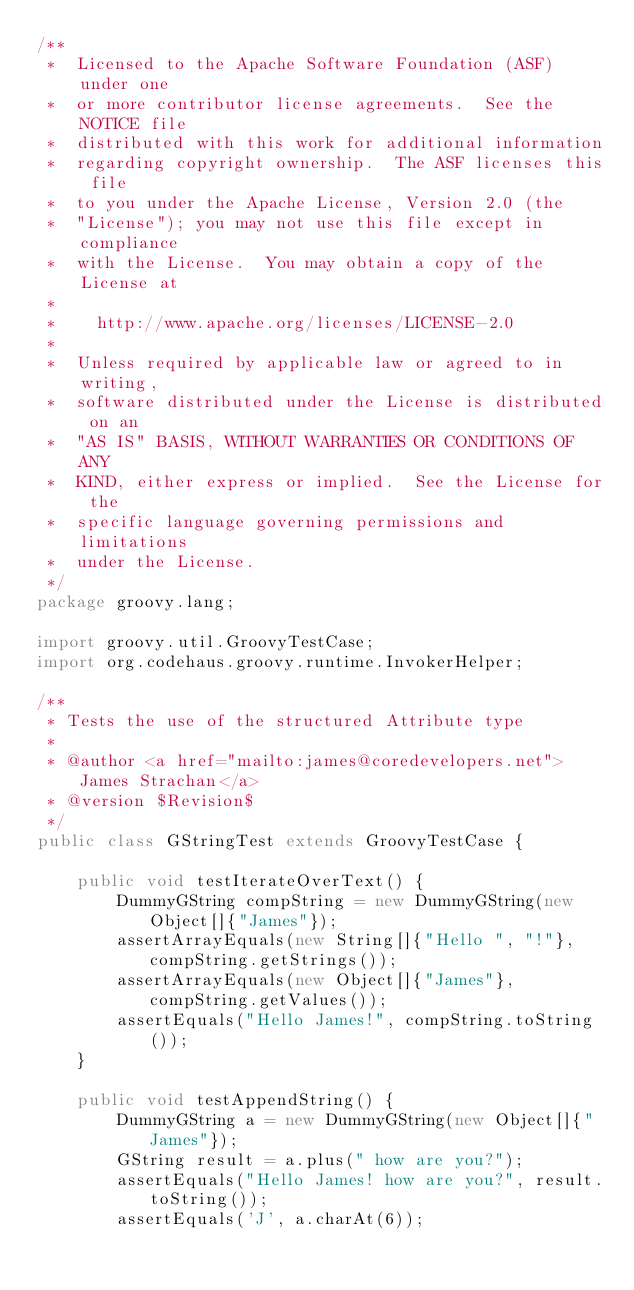<code> <loc_0><loc_0><loc_500><loc_500><_Java_>/**
 *  Licensed to the Apache Software Foundation (ASF) under one
 *  or more contributor license agreements.  See the NOTICE file
 *  distributed with this work for additional information
 *  regarding copyright ownership.  The ASF licenses this file
 *  to you under the Apache License, Version 2.0 (the
 *  "License"); you may not use this file except in compliance
 *  with the License.  You may obtain a copy of the License at
 *
 *    http://www.apache.org/licenses/LICENSE-2.0
 *
 *  Unless required by applicable law or agreed to in writing,
 *  software distributed under the License is distributed on an
 *  "AS IS" BASIS, WITHOUT WARRANTIES OR CONDITIONS OF ANY
 *  KIND, either express or implied.  See the License for the
 *  specific language governing permissions and limitations
 *  under the License.
 */
package groovy.lang;

import groovy.util.GroovyTestCase;
import org.codehaus.groovy.runtime.InvokerHelper;

/**
 * Tests the use of the structured Attribute type
 *
 * @author <a href="mailto:james@coredevelopers.net">James Strachan</a>
 * @version $Revision$
 */
public class GStringTest extends GroovyTestCase {

    public void testIterateOverText() {
        DummyGString compString = new DummyGString(new Object[]{"James"});
        assertArrayEquals(new String[]{"Hello ", "!"}, compString.getStrings());
        assertArrayEquals(new Object[]{"James"}, compString.getValues());
        assertEquals("Hello James!", compString.toString());
    }

    public void testAppendString() {
        DummyGString a = new DummyGString(new Object[]{"James"});
        GString result = a.plus(" how are you?");
        assertEquals("Hello James! how are you?", result.toString());
        assertEquals('J', a.charAt(6));</code> 